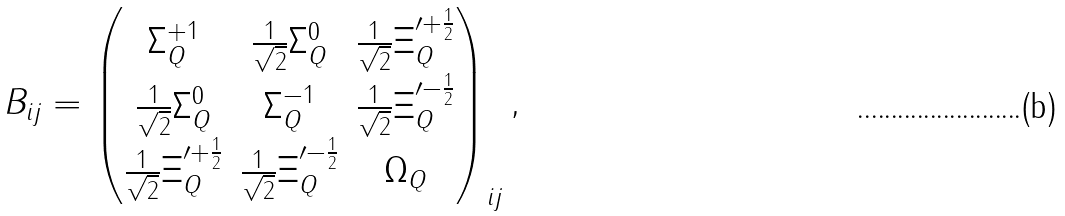Convert formula to latex. <formula><loc_0><loc_0><loc_500><loc_500>B _ { i j } = \begin{pmatrix} \Sigma _ { Q } ^ { + 1 } & \frac { 1 } { \sqrt { 2 } } \Sigma _ { Q } ^ { 0 } & \frac { 1 } { \sqrt { 2 } } \Xi _ { Q } ^ { \prime + \frac { 1 } { 2 } } \\ \frac { 1 } { \sqrt { 2 } } \Sigma _ { Q } ^ { 0 } & \Sigma _ { Q } ^ { - 1 } & \frac { 1 } { \sqrt { 2 } } \Xi _ { Q } ^ { \prime - \frac { 1 } { 2 } } \\ \frac { 1 } { \sqrt { 2 } } \Xi _ { Q } ^ { \prime + \frac { 1 } { 2 } } & \frac { 1 } { \sqrt { 2 } } \Xi _ { Q } ^ { \prime - \frac { 1 } { 2 } } & \Omega _ { Q } \end{pmatrix} _ { i j } ,</formula> 